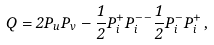Convert formula to latex. <formula><loc_0><loc_0><loc_500><loc_500>Q = 2 P _ { u } P _ { v } - \frac { 1 } { 2 } P _ { i } ^ { + } P _ { i } ^ { - - } \frac { 1 } { 2 } P _ { i } ^ { - } P _ { i } ^ { + } \, ,</formula> 